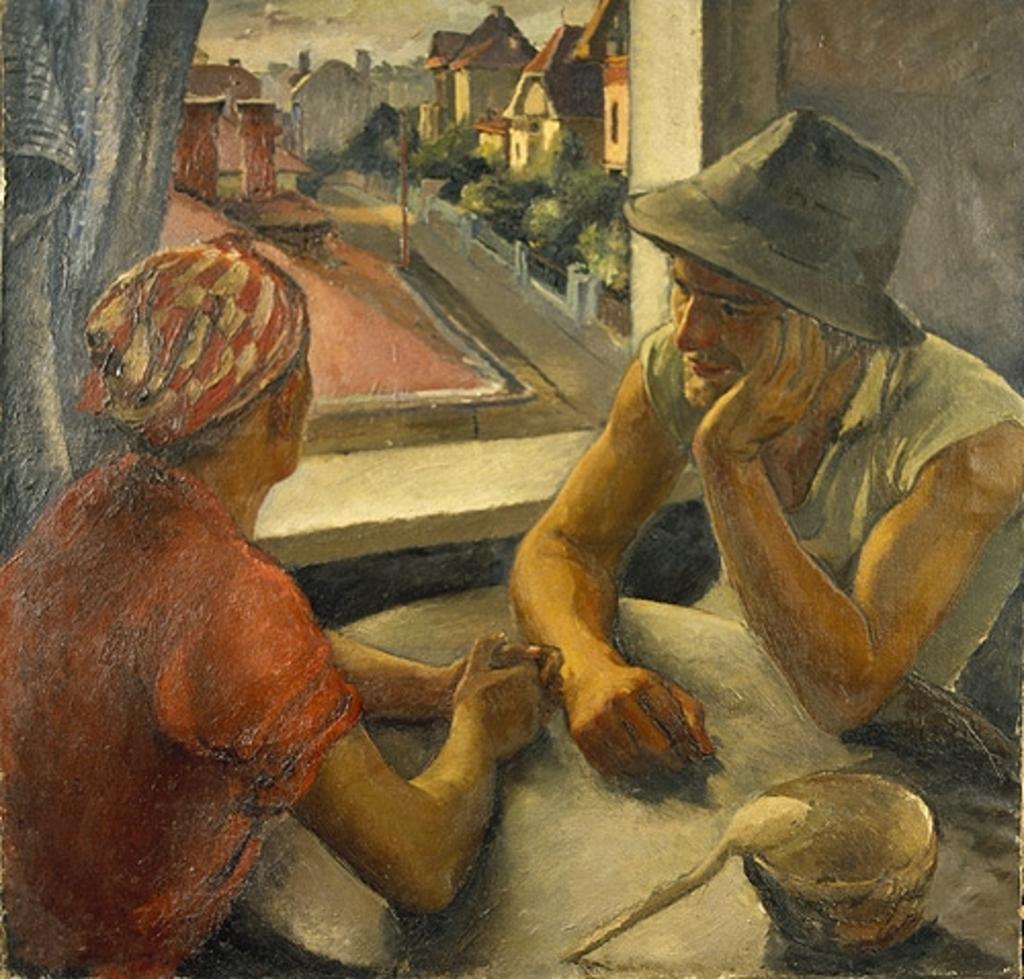How would you summarize this image in a sentence or two? This picture consists of a painting. In the foreground we can see the two people sitting and we can see the table, a bowl and a spoon. In the background we can see the curtain and the window and through the window we can see the sky, houses, trees, ground and some other items. 